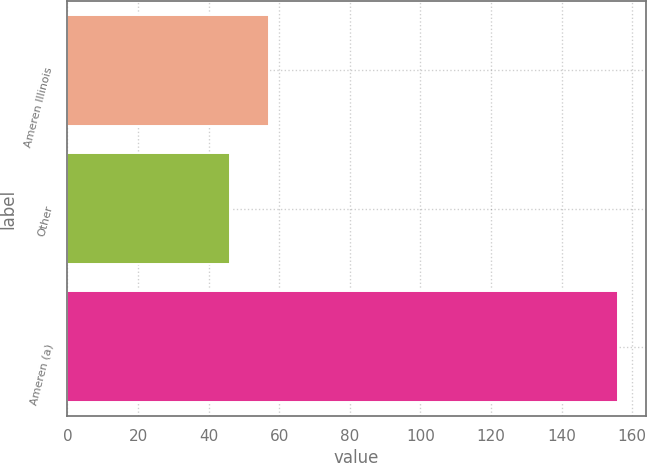Convert chart to OTSL. <chart><loc_0><loc_0><loc_500><loc_500><bar_chart><fcel>Ameren Illinois<fcel>Other<fcel>Ameren (a)<nl><fcel>57<fcel>46<fcel>156<nl></chart> 